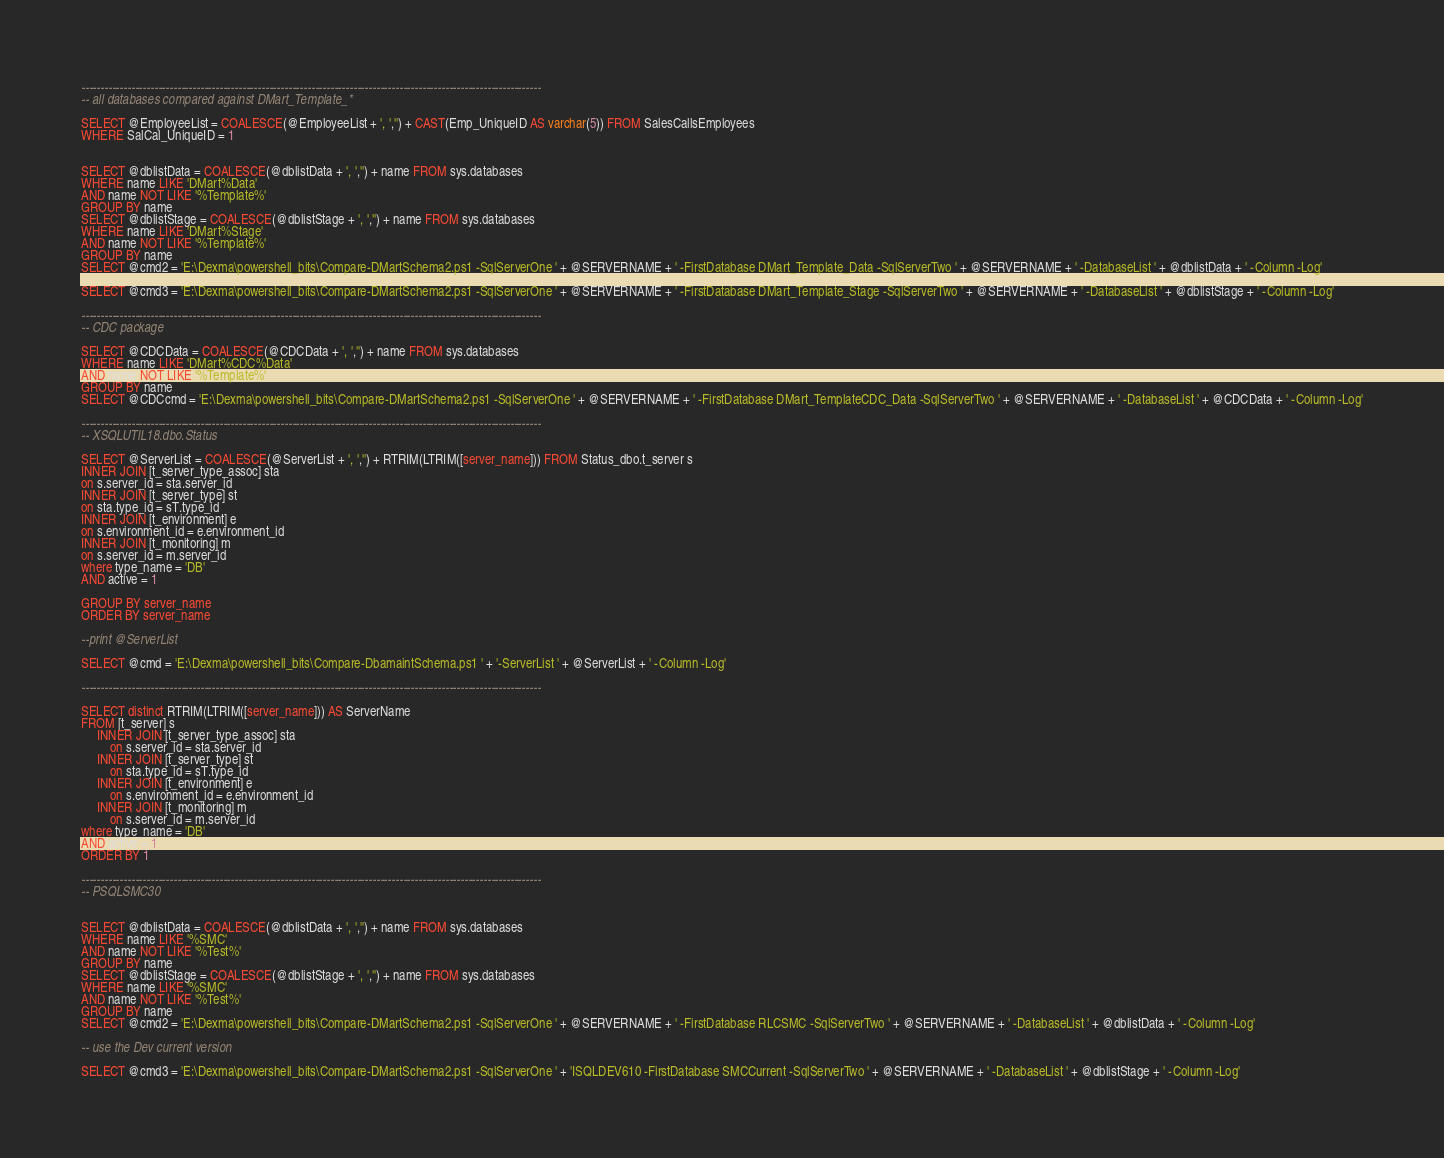Convert code to text. <code><loc_0><loc_0><loc_500><loc_500><_SQL_>------------------------------------------------------------------------------------------------------------------------
-- all databases compared against DMart_Template_*

SELECT @EmployeeList = COALESCE(@EmployeeList + ', ','') + CAST(Emp_UniqueID AS varchar(5)) FROM SalesCallsEmployees
WHERE SalCal_UniqueID = 1


SELECT @dblistData = COALESCE(@dblistData + ', ','') + name FROM sys.databases
WHERE name LIKE 'DMart%Data'
AND name NOT LIKE '%Template%'
GROUP BY name
SELECT @dblistStage = COALESCE(@dblistStage + ', ','') + name FROM sys.databases
WHERE name LIKE 'DMart%Stage'
AND name NOT LIKE '%Template%'
GROUP BY name
SELECT @cmd2 = 'E:\Dexma\powershell_bits\Compare-DMartSchema2.ps1 -SqlServerOne ' + @SERVERNAME + ' -FirstDatabase DMart_Template_Data -SqlServerTwo ' + @SERVERNAME + ' -DatabaseList ' + @dblistData + ' -Column -Log'

SELECT @cmd3 = 'E:\Dexma\powershell_bits\Compare-DMartSchema2.ps1 -SqlServerOne ' + @SERVERNAME + ' -FirstDatabase DMart_Template_Stage -SqlServerTwo ' + @SERVERNAME + ' -DatabaseList ' + @dblistStage + ' -Column -Log'

------------------------------------------------------------------------------------------------------------------------
-- CDC package

SELECT @CDCData = COALESCE(@CDCData + ', ','') + name FROM sys.databases
WHERE name LIKE 'DMart%CDC%Data'
AND name NOT LIKE '%Template%'
GROUP BY name
SELECT @CDCcmd = 'E:\Dexma\powershell_bits\Compare-DMartSchema2.ps1 -SqlServerOne ' + @SERVERNAME + ' -FirstDatabase DMart_TemplateCDC_Data -SqlServerTwo ' + @SERVERNAME + ' -DatabaseList ' + @CDCData + ' -Column -Log'

------------------------------------------------------------------------------------------------------------------------
-- XSQLUTIL18.dbo.Status

SELECT @ServerList = COALESCE(@ServerList + ', ','') + RTRIM(LTRIM([server_name])) FROM Status_dbo.t_server s
INNER JOIN [t_server_type_assoc] sta
on s.server_id = sta.server_id
INNER JOIN [t_server_type] st
on sta.type_id = sT.type_id
INNER JOIN [t_environment] e
on s.environment_id = e.environment_id
INNER JOIN [t_monitoring] m
on s.server_id = m.server_id
where type_name = 'DB'
AND active = 1

GROUP BY server_name
ORDER BY server_name

--print @ServerList

SELECT @cmd = 'E:\Dexma\powershell_bits\Compare-DbamaintSchema.ps1 ' + '-ServerList ' + @ServerList + ' -Column -Log'
                
------------------------------------------------------------------------------------------------------------------------

SELECT distinct RTRIM(LTRIM([server_name])) AS ServerName
FROM [t_server] s
     INNER JOIN [t_server_type_assoc] sta
         on s.server_id = sta.server_id
     INNER JOIN [t_server_type] st
         on sta.type_id = sT.type_id
     INNER JOIN [t_environment] e
         on s.environment_id = e.environment_id
     INNER JOIN [t_monitoring] m
         on s.server_id = m.server_id
where type_name = 'DB'
AND active = 1
ORDER BY 1
    
------------------------------------------------------------------------------------------------------------------------
-- PSQLSMC30


SELECT @dblistData = COALESCE(@dblistData + ', ','') + name FROM sys.databases
WHERE name LIKE '%SMC'
AND name NOT LIKE '%Test%'
GROUP BY name
SELECT @dblistStage = COALESCE(@dblistStage + ', ','') + name FROM sys.databases
WHERE name LIKE '%SMC'
AND name NOT LIKE '%Test%'
GROUP BY name
SELECT @cmd2 = 'E:\Dexma\powershell_bits\Compare-DMartSchema2.ps1 -SqlServerOne ' + @SERVERNAME + ' -FirstDatabase RLCSMC -SqlServerTwo ' + @SERVERNAME + ' -DatabaseList ' + @dblistData + ' -Column -Log'

-- use the Dev current version

SELECT @cmd3 = 'E:\Dexma\powershell_bits\Compare-DMartSchema2.ps1 -SqlServerOne ' + 'ISQLDEV610 -FirstDatabase SMCCurrent -SqlServerTwo ' + @SERVERNAME + ' -DatabaseList ' + @dblistStage + ' -Column -Log'</code> 